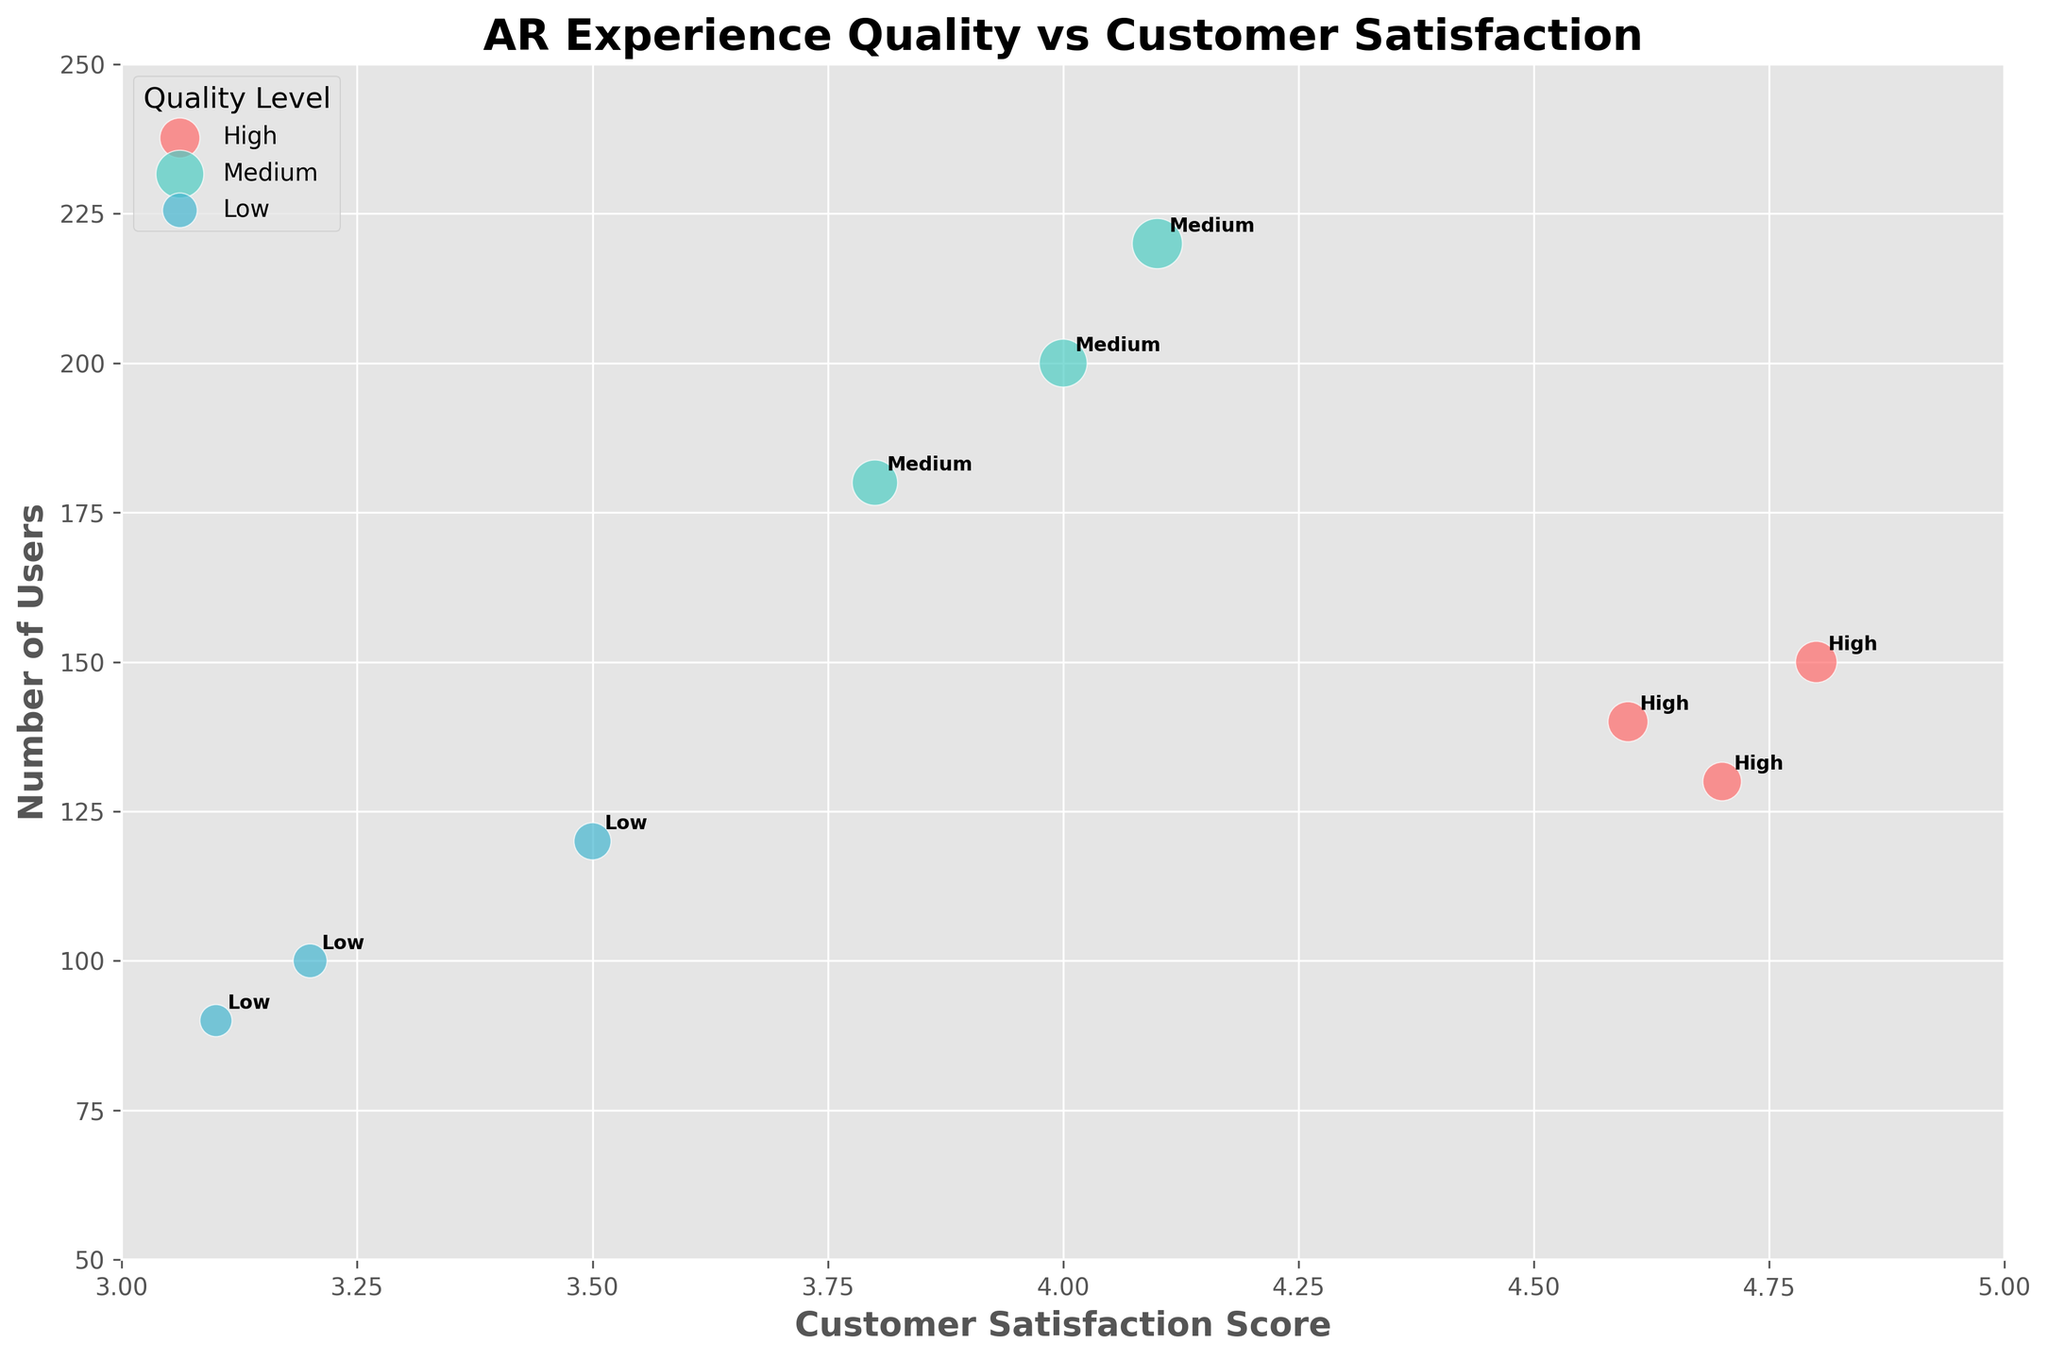What is the title of the chart? The title of the chart is positioned at the top center. It indicates the main topic of the chart.
Answer: AR Experience Quality vs Customer Satisfaction What are the labels of the axes? The x-axis label is "Customer Satisfaction Score," and the y-axis label is "Number of Users." These labels describe what each axis represents.
Answer: Customer Satisfaction Score, Number of Users How many different Quality Levels are represented in the chart? By observing the legend on the chart, it shows three distinct colors, each representing a Quality Level: High, Medium, and Low.
Answer: 3 Which Quality Level has the highest Customer Satisfaction Score? By looking at the x-axis values and comparing the points, the "High" Quality Level has the highest score at 4.8.
Answer: High Which Quality Level has the largest number of users? Observing the y-axis and the size of the bubbles, the "Medium" Quality Level has the largest number of users, reaching 220.
Answer: Medium What is the average Customer Satisfaction Score for the High-Quality Level? The scores for High-Quality Level are 4.8, 4.7, and 4.6. Calculate the average: (4.8 + 4.7 + 4.6) / 3 = 4.7
Answer: 4.7 Compare the average Customer Satisfaction Score between Medium and Low Quality Levels. Which is higher? The Medium scores are 4.0, 3.8, 4.1; average is (4.0 + 3.8 + 4.1) / 3 = 3.97. The Low scores are 3.2, 3.5, 3.1; average is (3.2 + 3.5 + 3.1) / 3 = 3.27. The average for Medium is higher.
Answer: Medium Which Quality Level has the smallest bubble for the number of users? The smallest bubble represents the lowest "Number of Users." Observing visually, the smallest bubble corresponds to the Low Quality Level with 90 users.
Answer: Low What is the difference in Customer Satisfaction Score between the highest and lowest scores? The highest score is 4.8 (High Quality), and the lowest is 3.1 (Low Quality). The difference is 4.8 - 3.1 = 1.7.
Answer: 1.7 Which Quality Level appears most frequently in the chart? By counting the number of bubbles for each Quality Level: High (3 bubbles), Medium (3 bubbles), Low (3 bubbles). They all appear equally.
Answer: AllEqual 